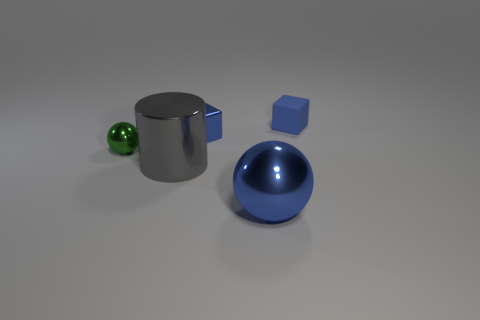How many blue cubes must be subtracted to get 1 blue cubes? 1 Add 2 shiny balls. How many objects exist? 7 Subtract all balls. How many objects are left? 3 Add 4 green objects. How many green objects are left? 5 Add 3 blue metallic balls. How many blue metallic balls exist? 4 Subtract 0 gray cubes. How many objects are left? 5 Subtract all shiny blocks. Subtract all green metallic balls. How many objects are left? 3 